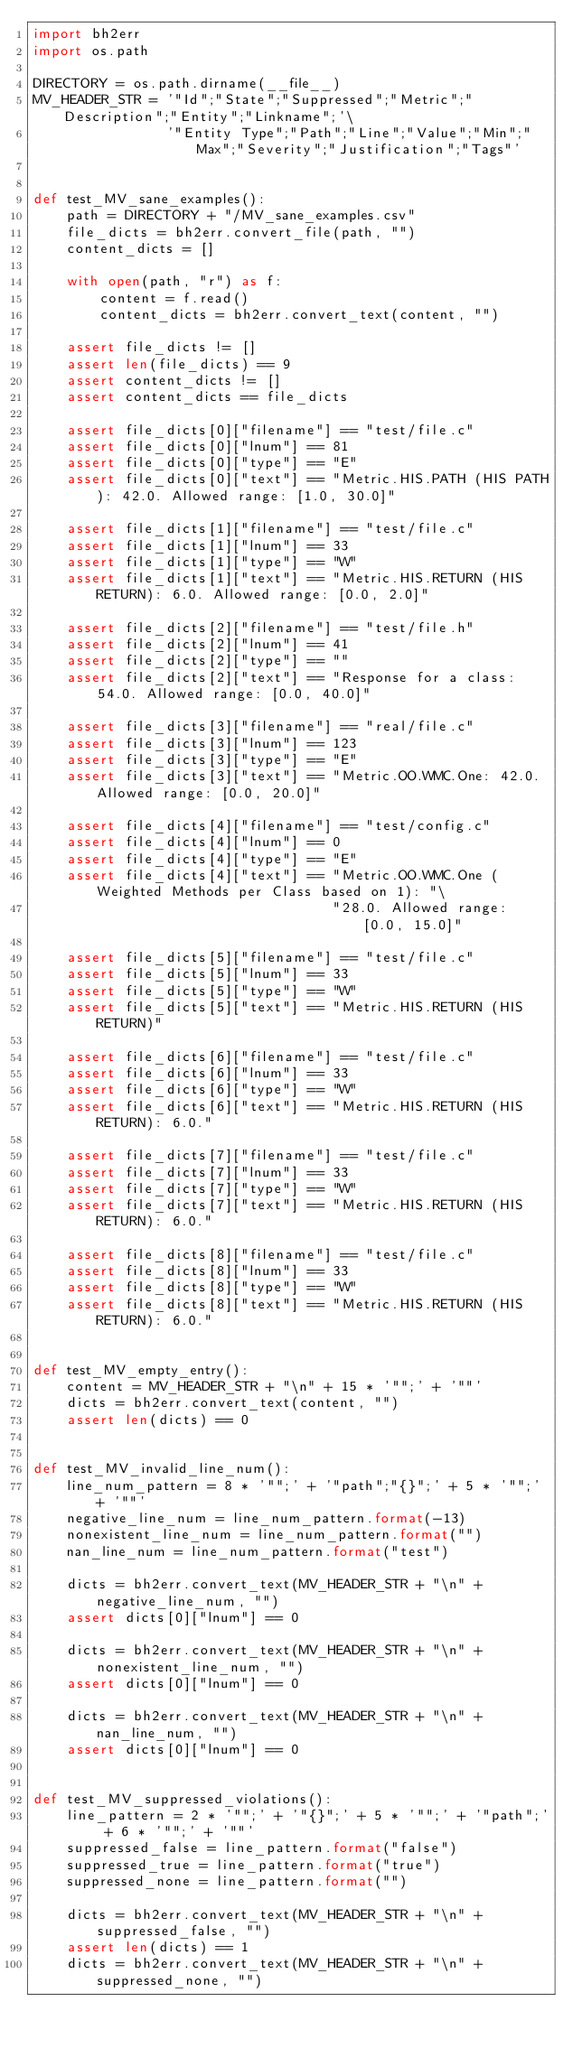Convert code to text. <code><loc_0><loc_0><loc_500><loc_500><_Python_>import bh2err
import os.path

DIRECTORY = os.path.dirname(__file__)
MV_HEADER_STR = '"Id";"State";"Suppressed";"Metric";"Description";"Entity";"Linkname";'\
                '"Entity Type";"Path";"Line";"Value";"Min";"Max";"Severity";"Justification";"Tags"'


def test_MV_sane_examples():
    path = DIRECTORY + "/MV_sane_examples.csv"
    file_dicts = bh2err.convert_file(path, "")
    content_dicts = []

    with open(path, "r") as f:
        content = f.read()
        content_dicts = bh2err.convert_text(content, "")

    assert file_dicts != []
    assert len(file_dicts) == 9
    assert content_dicts != []
    assert content_dicts == file_dicts

    assert file_dicts[0]["filename"] == "test/file.c"
    assert file_dicts[0]["lnum"] == 81
    assert file_dicts[0]["type"] == "E"
    assert file_dicts[0]["text"] == "Metric.HIS.PATH (HIS PATH): 42.0. Allowed range: [1.0, 30.0]"

    assert file_dicts[1]["filename"] == "test/file.c"
    assert file_dicts[1]["lnum"] == 33
    assert file_dicts[1]["type"] == "W"
    assert file_dicts[1]["text"] == "Metric.HIS.RETURN (HIS RETURN): 6.0. Allowed range: [0.0, 2.0]"

    assert file_dicts[2]["filename"] == "test/file.h"
    assert file_dicts[2]["lnum"] == 41
    assert file_dicts[2]["type"] == ""
    assert file_dicts[2]["text"] == "Response for a class: 54.0. Allowed range: [0.0, 40.0]"

    assert file_dicts[3]["filename"] == "real/file.c"
    assert file_dicts[3]["lnum"] == 123
    assert file_dicts[3]["type"] == "E"
    assert file_dicts[3]["text"] == "Metric.OO.WMC.One: 42.0. Allowed range: [0.0, 20.0]"

    assert file_dicts[4]["filename"] == "test/config.c"
    assert file_dicts[4]["lnum"] == 0
    assert file_dicts[4]["type"] == "E"
    assert file_dicts[4]["text"] == "Metric.OO.WMC.One (Weighted Methods per Class based on 1): "\
                                    "28.0. Allowed range: [0.0, 15.0]"

    assert file_dicts[5]["filename"] == "test/file.c"
    assert file_dicts[5]["lnum"] == 33
    assert file_dicts[5]["type"] == "W"
    assert file_dicts[5]["text"] == "Metric.HIS.RETURN (HIS RETURN)"

    assert file_dicts[6]["filename"] == "test/file.c"
    assert file_dicts[6]["lnum"] == 33
    assert file_dicts[6]["type"] == "W"
    assert file_dicts[6]["text"] == "Metric.HIS.RETURN (HIS RETURN): 6.0."

    assert file_dicts[7]["filename"] == "test/file.c"
    assert file_dicts[7]["lnum"] == 33
    assert file_dicts[7]["type"] == "W"
    assert file_dicts[7]["text"] == "Metric.HIS.RETURN (HIS RETURN): 6.0."

    assert file_dicts[8]["filename"] == "test/file.c"
    assert file_dicts[8]["lnum"] == 33
    assert file_dicts[8]["type"] == "W"
    assert file_dicts[8]["text"] == "Metric.HIS.RETURN (HIS RETURN): 6.0."


def test_MV_empty_entry():
    content = MV_HEADER_STR + "\n" + 15 * '"";' + '""'
    dicts = bh2err.convert_text(content, "")
    assert len(dicts) == 0


def test_MV_invalid_line_num():
    line_num_pattern = 8 * '"";' + '"path";"{}";' + 5 * '"";' + '""'
    negative_line_num = line_num_pattern.format(-13)
    nonexistent_line_num = line_num_pattern.format("")
    nan_line_num = line_num_pattern.format("test")

    dicts = bh2err.convert_text(MV_HEADER_STR + "\n" + negative_line_num, "")
    assert dicts[0]["lnum"] == 0

    dicts = bh2err.convert_text(MV_HEADER_STR + "\n" + nonexistent_line_num, "")
    assert dicts[0]["lnum"] == 0

    dicts = bh2err.convert_text(MV_HEADER_STR + "\n" + nan_line_num, "")
    assert dicts[0]["lnum"] == 0


def test_MV_suppressed_violations():
    line_pattern = 2 * '"";' + '"{}";' + 5 * '"";' + '"path";' + 6 * '"";' + '""'
    suppressed_false = line_pattern.format("false")
    suppressed_true = line_pattern.format("true")
    suppressed_none = line_pattern.format("")

    dicts = bh2err.convert_text(MV_HEADER_STR + "\n" + suppressed_false, "")
    assert len(dicts) == 1
    dicts = bh2err.convert_text(MV_HEADER_STR + "\n" + suppressed_none, "")</code> 